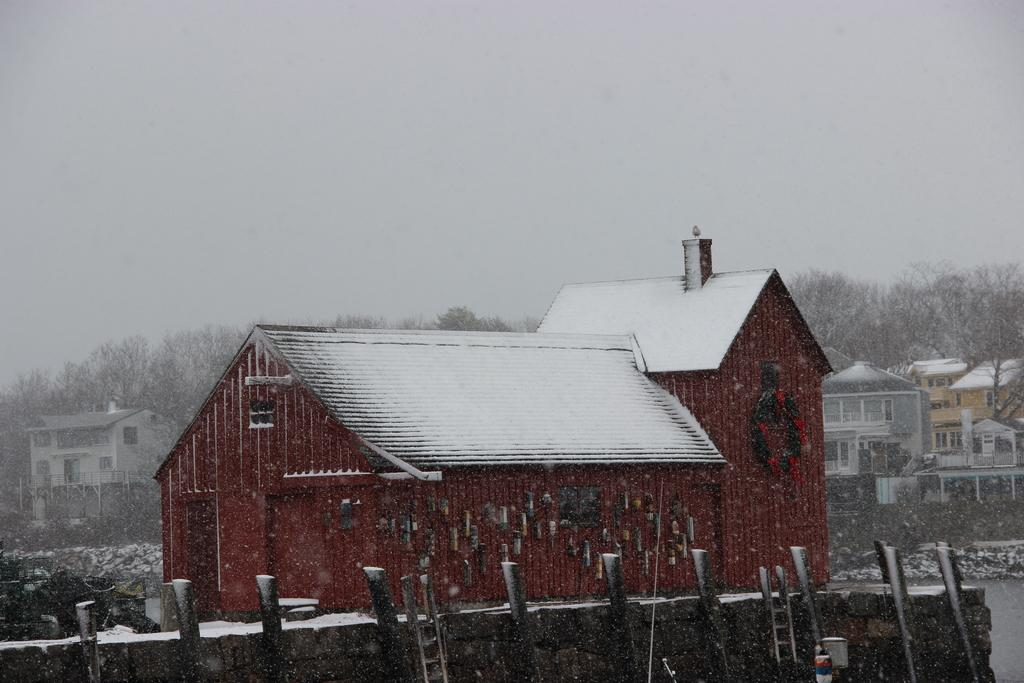What type of structures can be seen in the image? There are many buildings in the image. Where are the buildings located in relation to other features? The buildings are beside a lake. What other natural elements are present in the image? There are trees in the image. How is the weather depicted in the image? The trees are partially covered with snow, suggesting a cold or snowy environment. What type of scent can be detected from the cattle in the image? There are no cattle present in the image, so it is not possible to determine any scent. 